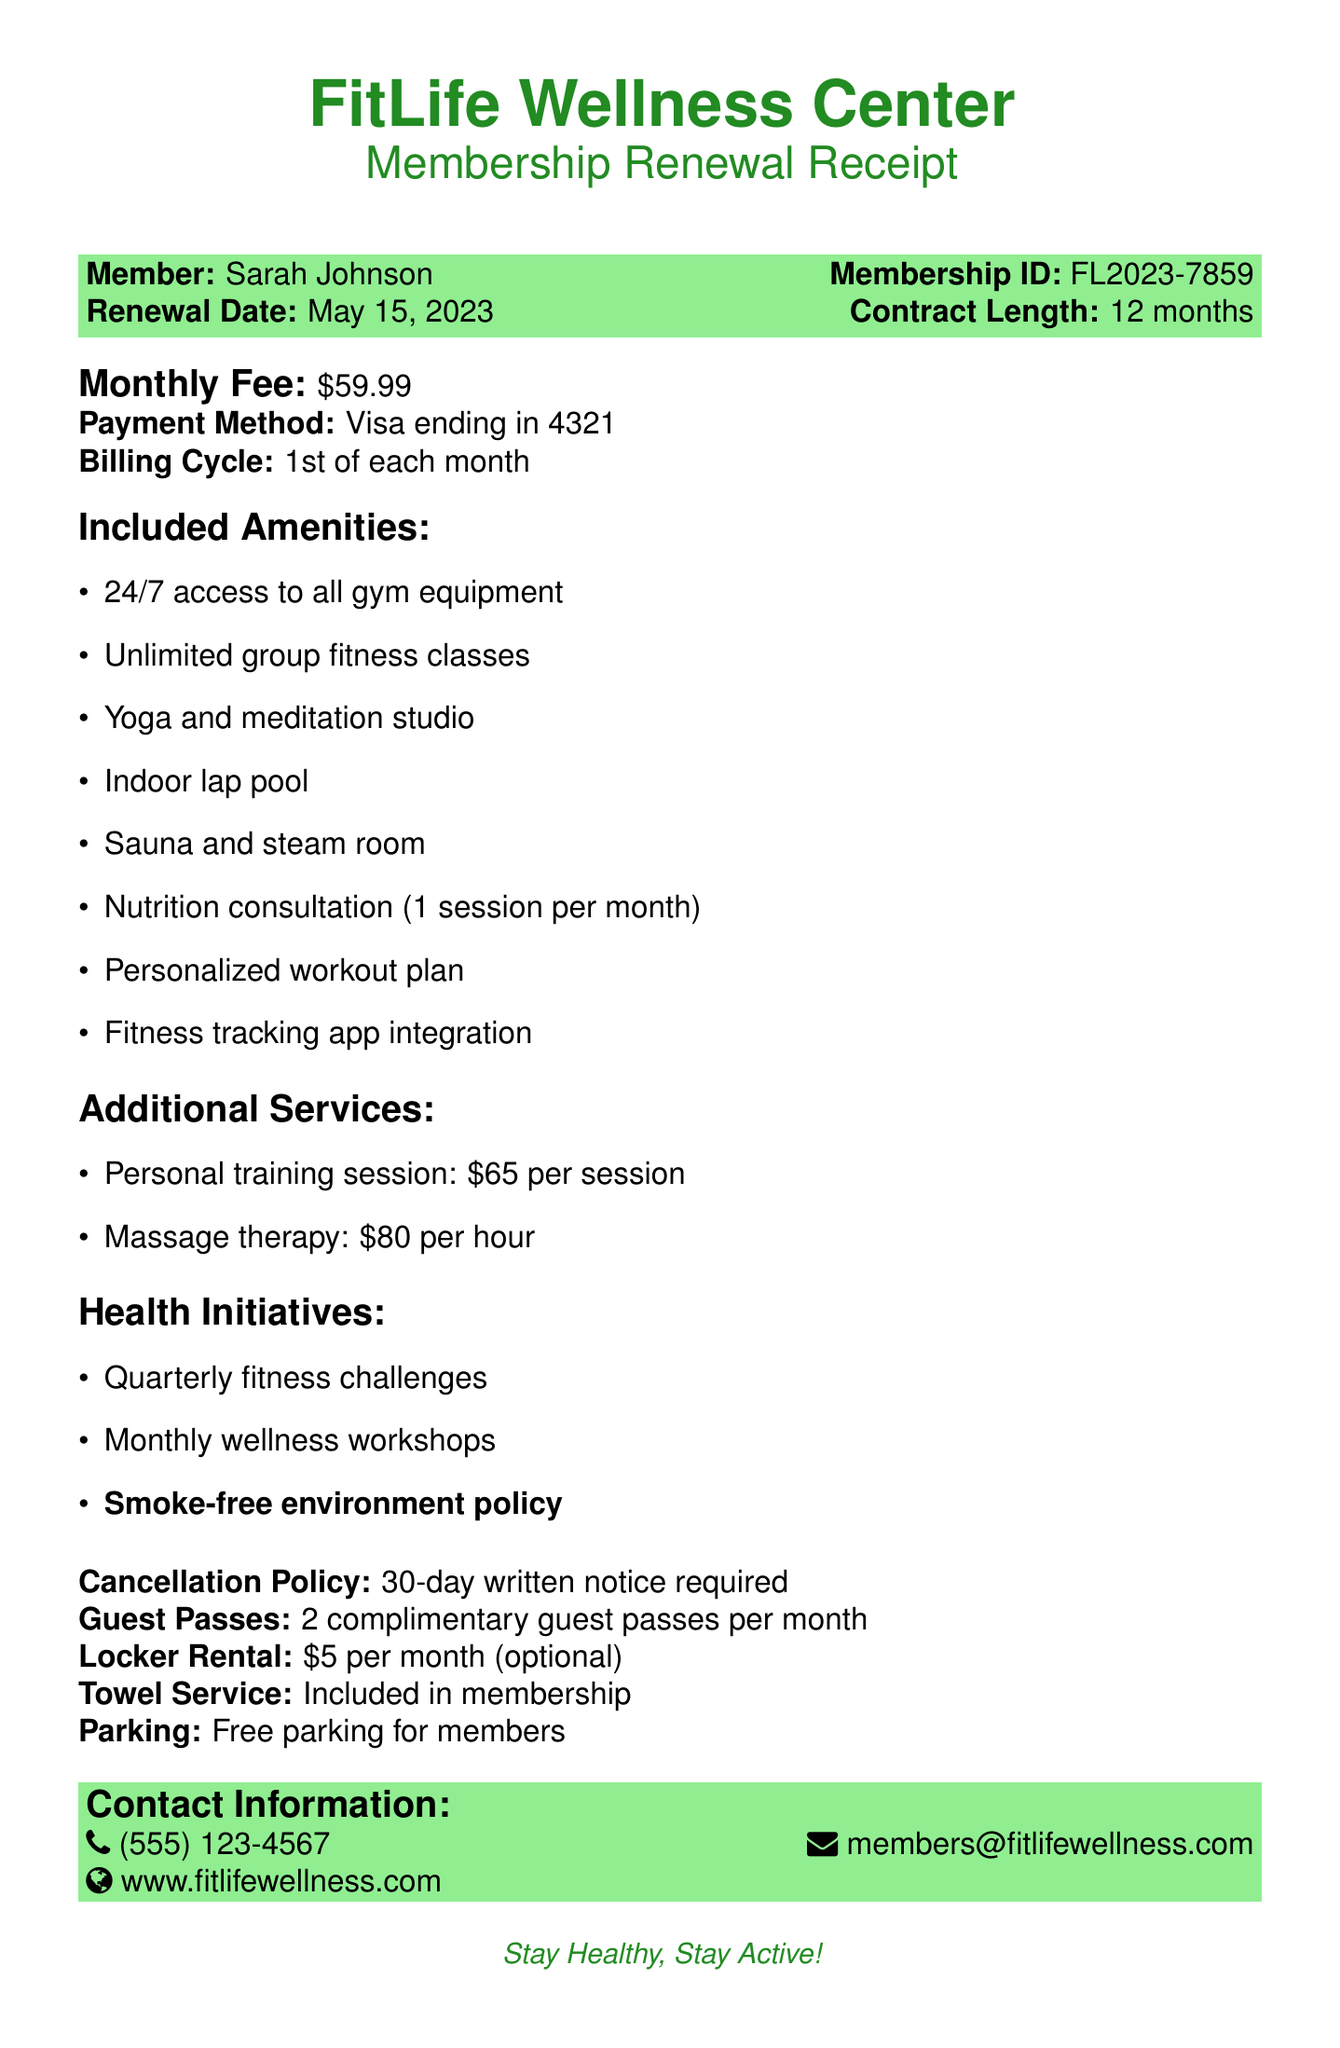What is the monthly fee for the gym membership? The monthly fee is explicitly stated in the document, which is $59.99.
Answer: $59.99 What is the contract length of the membership? The contract length is provided in the document as 12 months.
Answer: 12 months When is the renewal date for the membership? The renewal date is clearly mentioned in the document, which is May 15, 2023.
Answer: May 15, 2023 How many guest passes are included each month? The document states that members receive 2 complimentary guest passes per month.
Answer: 2 What is one of the health initiatives mentioned? The document lists health initiatives, one of which is quarterly fitness challenges.
Answer: Quarterly fitness challenges What amenities can be accessed 24/7? The document specifies that all gym equipment is available for 24/7 access.
Answer: All gym equipment How much does a personal training session cost? The document provides the pricing for personal training sessions as $65 per session.
Answer: $65 per session What is the cancellation policy duration? The document states that a 30-day written notice is required for cancellation.
Answer: 30 days What special policy regarding smoking is mentioned? The document emphasizes a commitment to health with a smoke-free environment policy.
Answer: Smoke-free environment policy 